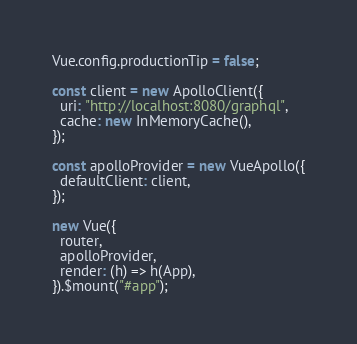Convert code to text. <code><loc_0><loc_0><loc_500><loc_500><_JavaScript_>Vue.config.productionTip = false;

const client = new ApolloClient({
  uri: "http://localhost:8080/graphql",
  cache: new InMemoryCache(),
});

const apolloProvider = new VueApollo({
  defaultClient: client,
});

new Vue({
  router,
  apolloProvider,
  render: (h) => h(App),
}).$mount("#app");
</code> 